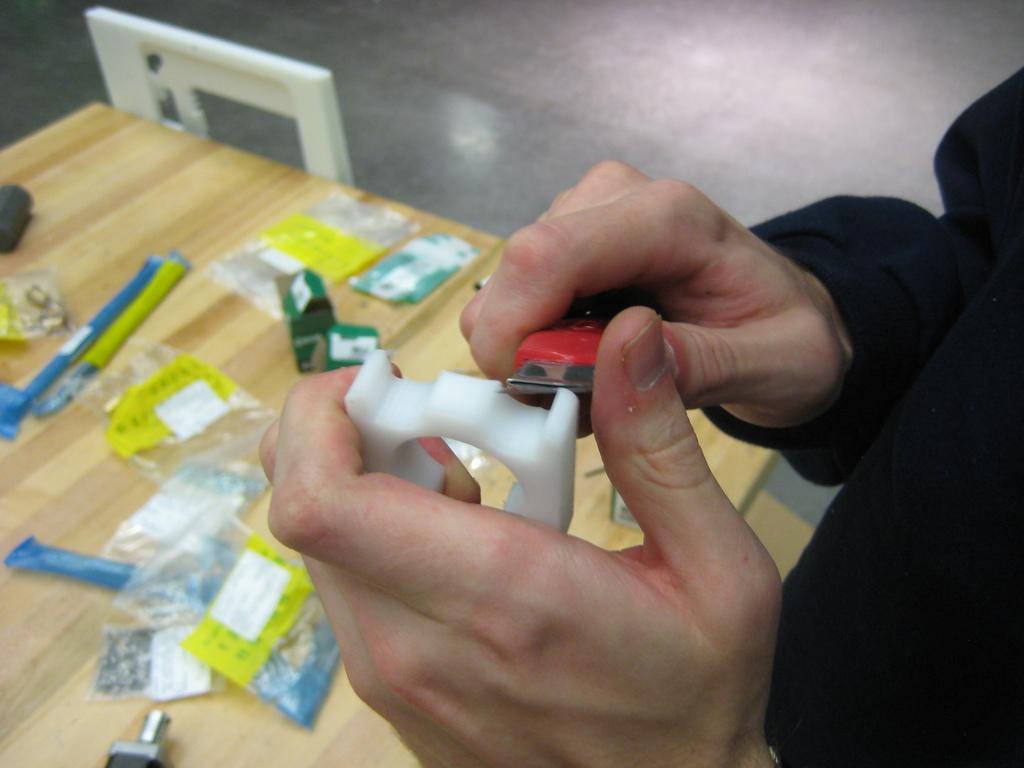Describe this image in one or two sentences. In this image in the foreground there is one person, who is holding some cutter and cutting something and at the bottom there is a table. On the table there are some pens plastic covers, and some other objects and there is one chair and in the background there is floor. 